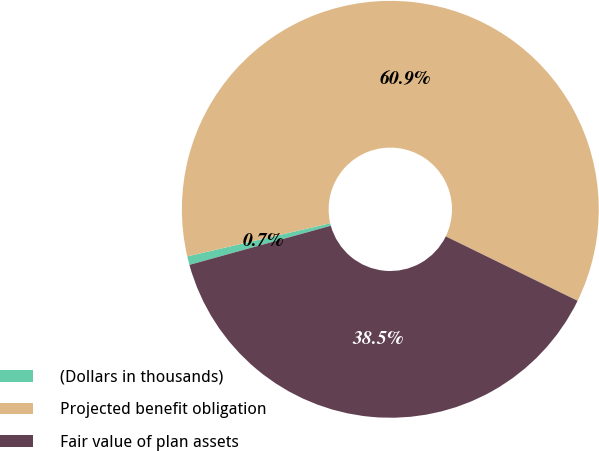Convert chart. <chart><loc_0><loc_0><loc_500><loc_500><pie_chart><fcel>(Dollars in thousands)<fcel>Projected benefit obligation<fcel>Fair value of plan assets<nl><fcel>0.67%<fcel>60.86%<fcel>38.47%<nl></chart> 